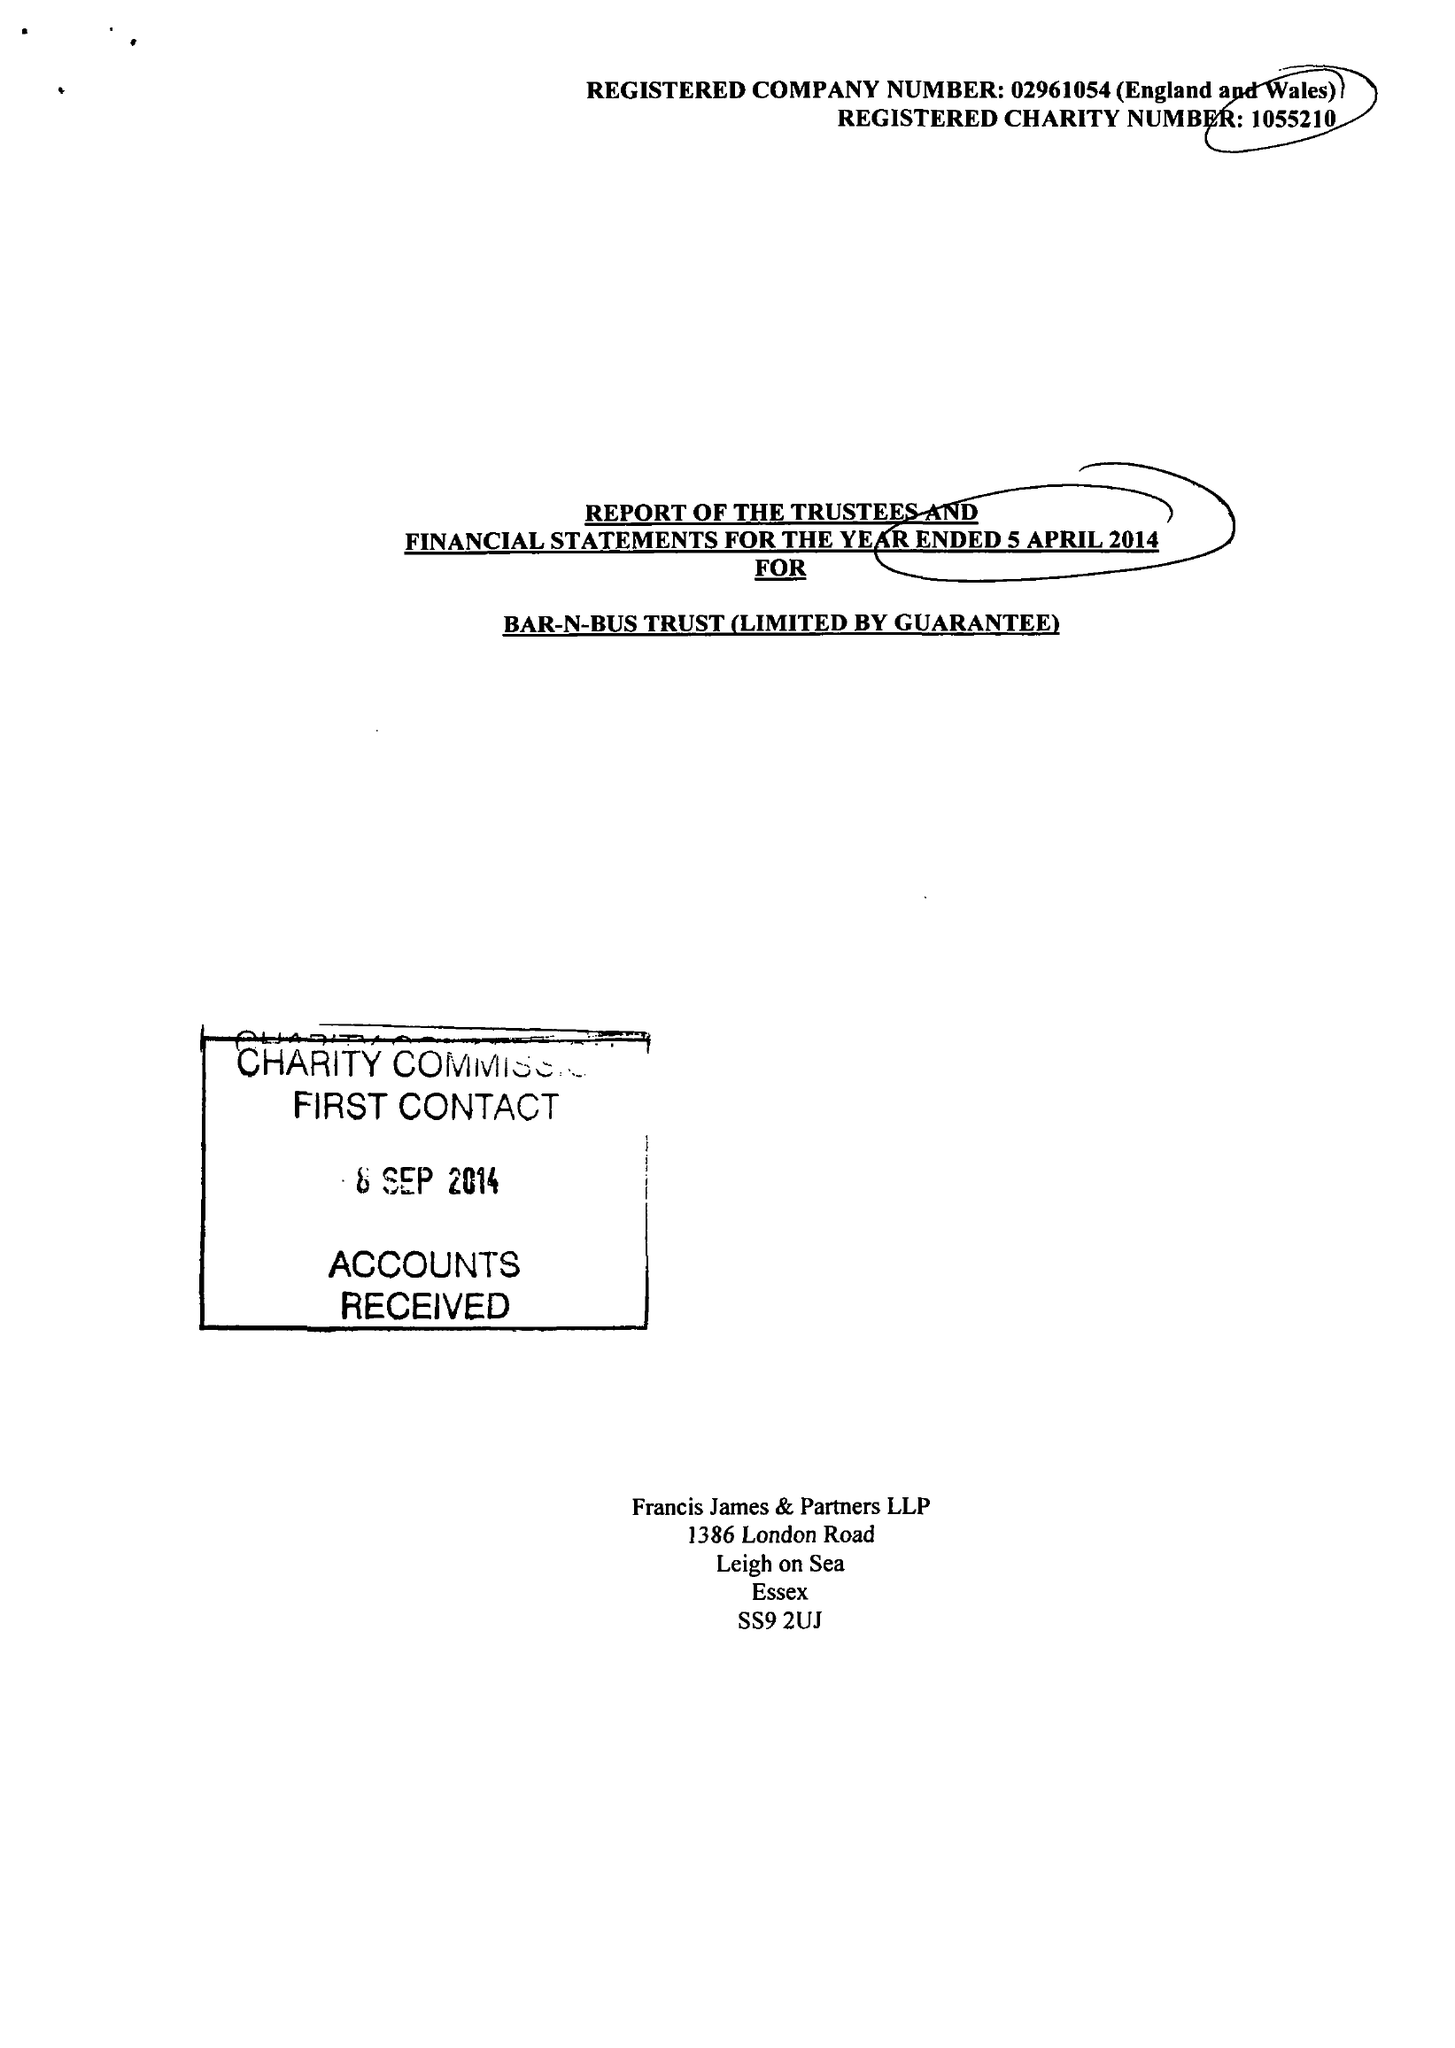What is the value for the charity_number?
Answer the question using a single word or phrase. 1055210 